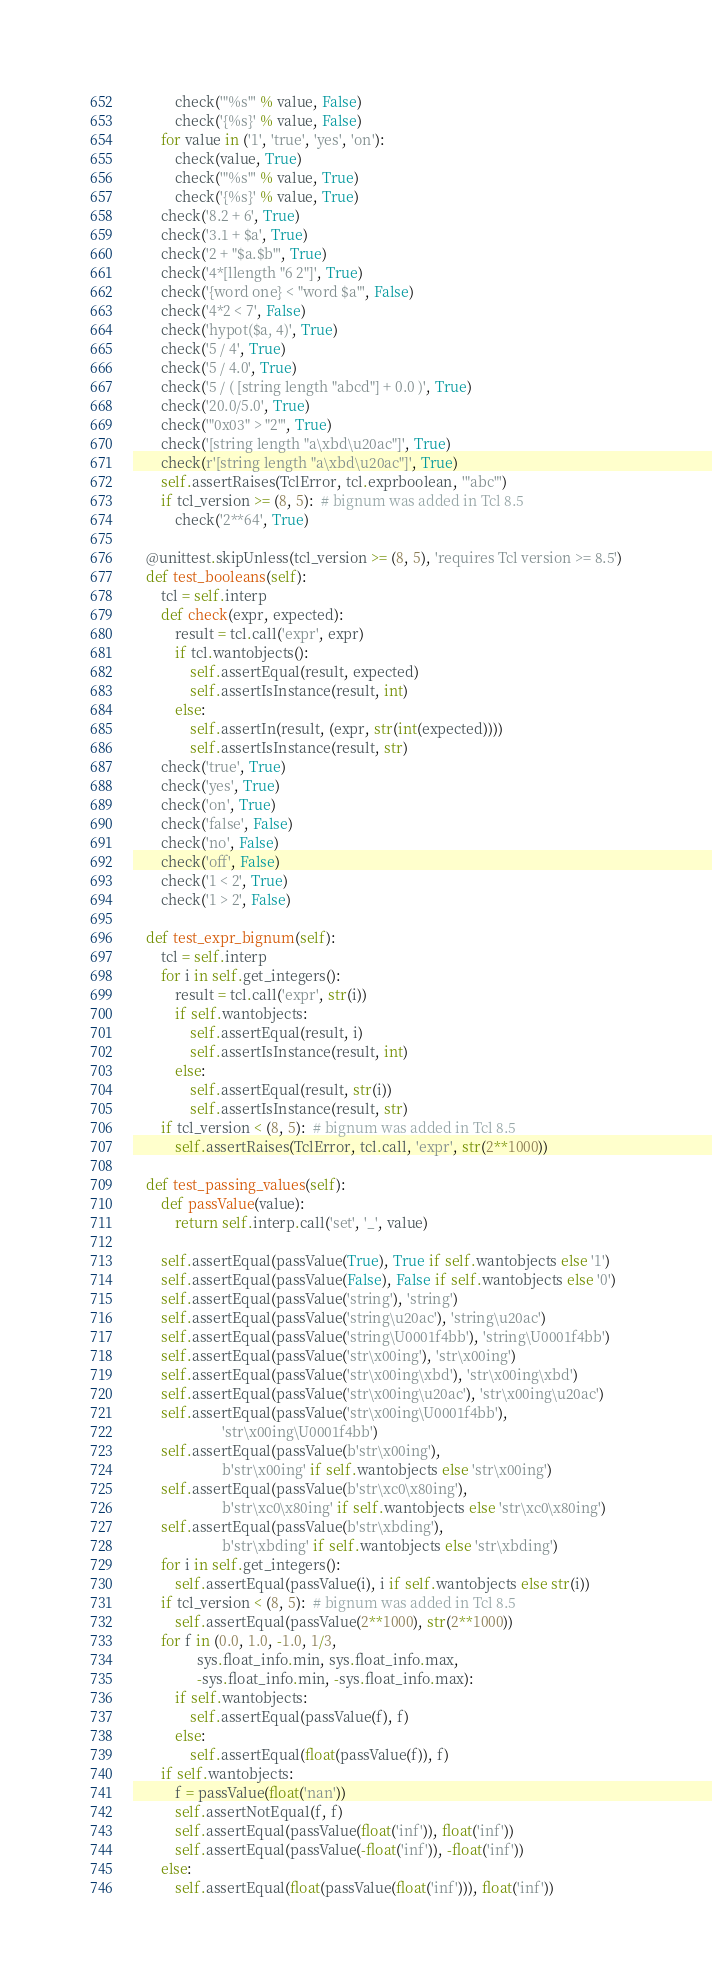Convert code to text. <code><loc_0><loc_0><loc_500><loc_500><_Python_>            check('"%s"' % value, False)
            check('{%s}' % value, False)
        for value in ('1', 'true', 'yes', 'on'):
            check(value, True)
            check('"%s"' % value, True)
            check('{%s}' % value, True)
        check('8.2 + 6', True)
        check('3.1 + $a', True)
        check('2 + "$a.$b"', True)
        check('4*[llength "6 2"]', True)
        check('{word one} < "word $a"', False)
        check('4*2 < 7', False)
        check('hypot($a, 4)', True)
        check('5 / 4', True)
        check('5 / 4.0', True)
        check('5 / ( [string length "abcd"] + 0.0 )', True)
        check('20.0/5.0', True)
        check('"0x03" > "2"', True)
        check('[string length "a\xbd\u20ac"]', True)
        check(r'[string length "a\xbd\u20ac"]', True)
        self.assertRaises(TclError, tcl.exprboolean, '"abc"')
        if tcl_version >= (8, 5):  # bignum was added in Tcl 8.5
            check('2**64', True)

    @unittest.skipUnless(tcl_version >= (8, 5), 'requires Tcl version >= 8.5')
    def test_booleans(self):
        tcl = self.interp
        def check(expr, expected):
            result = tcl.call('expr', expr)
            if tcl.wantobjects():
                self.assertEqual(result, expected)
                self.assertIsInstance(result, int)
            else:
                self.assertIn(result, (expr, str(int(expected))))
                self.assertIsInstance(result, str)
        check('true', True)
        check('yes', True)
        check('on', True)
        check('false', False)
        check('no', False)
        check('off', False)
        check('1 < 2', True)
        check('1 > 2', False)

    def test_expr_bignum(self):
        tcl = self.interp
        for i in self.get_integers():
            result = tcl.call('expr', str(i))
            if self.wantobjects:
                self.assertEqual(result, i)
                self.assertIsInstance(result, int)
            else:
                self.assertEqual(result, str(i))
                self.assertIsInstance(result, str)
        if tcl_version < (8, 5):  # bignum was added in Tcl 8.5
            self.assertRaises(TclError, tcl.call, 'expr', str(2**1000))

    def test_passing_values(self):
        def passValue(value):
            return self.interp.call('set', '_', value)

        self.assertEqual(passValue(True), True if self.wantobjects else '1')
        self.assertEqual(passValue(False), False if self.wantobjects else '0')
        self.assertEqual(passValue('string'), 'string')
        self.assertEqual(passValue('string\u20ac'), 'string\u20ac')
        self.assertEqual(passValue('string\U0001f4bb'), 'string\U0001f4bb')
        self.assertEqual(passValue('str\x00ing'), 'str\x00ing')
        self.assertEqual(passValue('str\x00ing\xbd'), 'str\x00ing\xbd')
        self.assertEqual(passValue('str\x00ing\u20ac'), 'str\x00ing\u20ac')
        self.assertEqual(passValue('str\x00ing\U0001f4bb'),
                         'str\x00ing\U0001f4bb')
        self.assertEqual(passValue(b'str\x00ing'),
                         b'str\x00ing' if self.wantobjects else 'str\x00ing')
        self.assertEqual(passValue(b'str\xc0\x80ing'),
                         b'str\xc0\x80ing' if self.wantobjects else 'str\xc0\x80ing')
        self.assertEqual(passValue(b'str\xbding'),
                         b'str\xbding' if self.wantobjects else 'str\xbding')
        for i in self.get_integers():
            self.assertEqual(passValue(i), i if self.wantobjects else str(i))
        if tcl_version < (8, 5):  # bignum was added in Tcl 8.5
            self.assertEqual(passValue(2**1000), str(2**1000))
        for f in (0.0, 1.0, -1.0, 1/3,
                  sys.float_info.min, sys.float_info.max,
                  -sys.float_info.min, -sys.float_info.max):
            if self.wantobjects:
                self.assertEqual(passValue(f), f)
            else:
                self.assertEqual(float(passValue(f)), f)
        if self.wantobjects:
            f = passValue(float('nan'))
            self.assertNotEqual(f, f)
            self.assertEqual(passValue(float('inf')), float('inf'))
            self.assertEqual(passValue(-float('inf')), -float('inf'))
        else:
            self.assertEqual(float(passValue(float('inf'))), float('inf'))</code> 